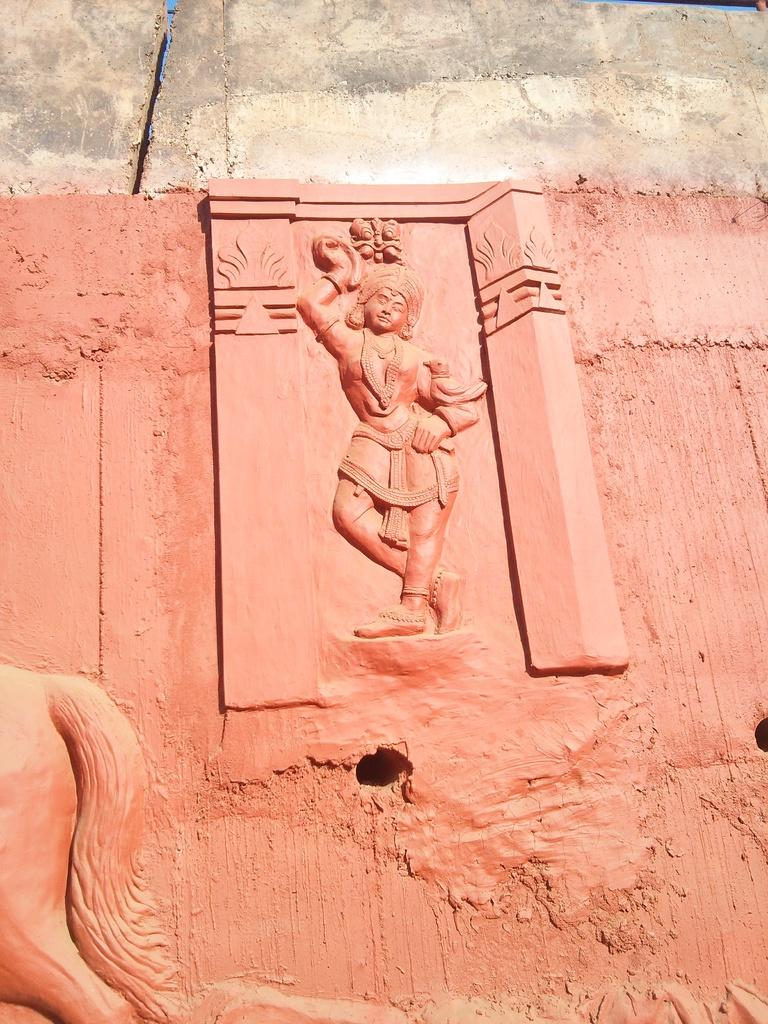What is present on the wall in the image? There are sculptures on the wall in the image. What is the condition of the wall? There are holes at the bottom of the wall. Can you see a tiger walking through the cemetery in the image? There is no tiger or cemetery present in the image. 